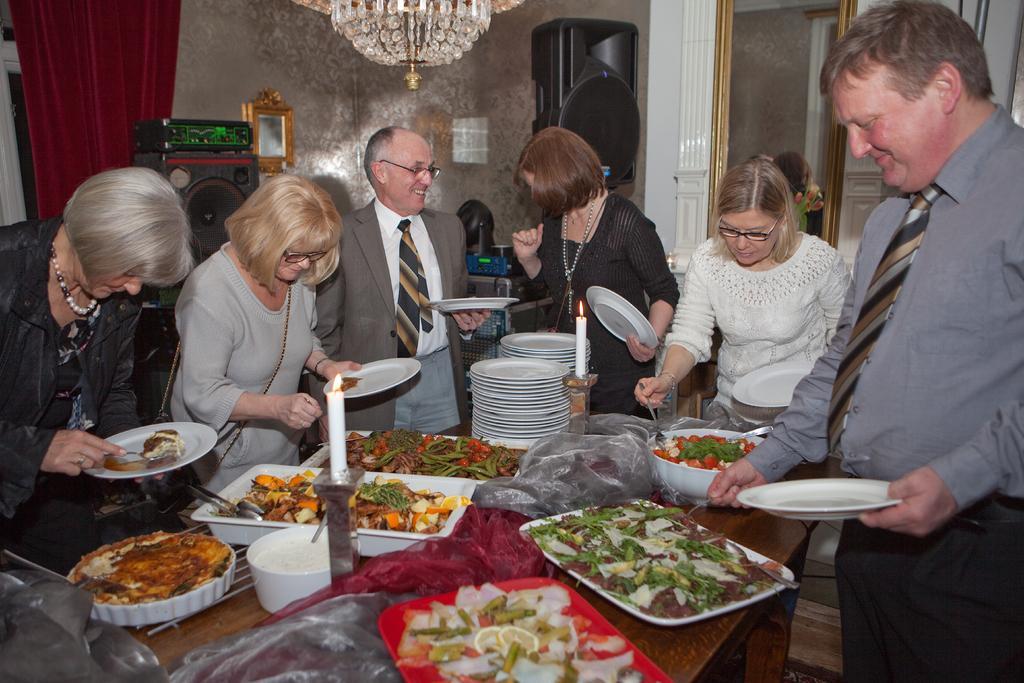Describe this image in one or two sentences. In this picture there are group of people standing and holding the plates. There are different food items on the plates and in the bowls and there are plates, bowls and candles on the table. At the back there are speakers and there are objects on the table and there is a curtain and window and there is a mirror. At the top there is a chandelier. At the bottom there is a floor. 